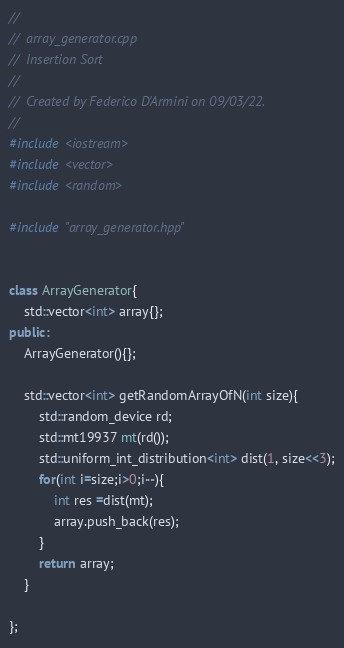Convert code to text. <code><loc_0><loc_0><loc_500><loc_500><_C++_>//
//  array_generator.cpp
//  Insertion Sort
//
//  Created by Federico D'Armini on 09/03/22.
//
#include <iostream>
#include <vector>
#include <random>

#include "array_generator.hpp"


class ArrayGenerator{
    std::vector<int> array{};
public:
    ArrayGenerator(){};
    
    std::vector<int> getRandomArrayOfN(int size){
        std::random_device rd;
        std::mt19937 mt(rd());
        std::uniform_int_distribution<int> dist(1, size<<3);
        for(int i=size;i>0;i--){
            int res =dist(mt);
            array.push_back(res);
        }
        return array;
    }
    
};
</code> 